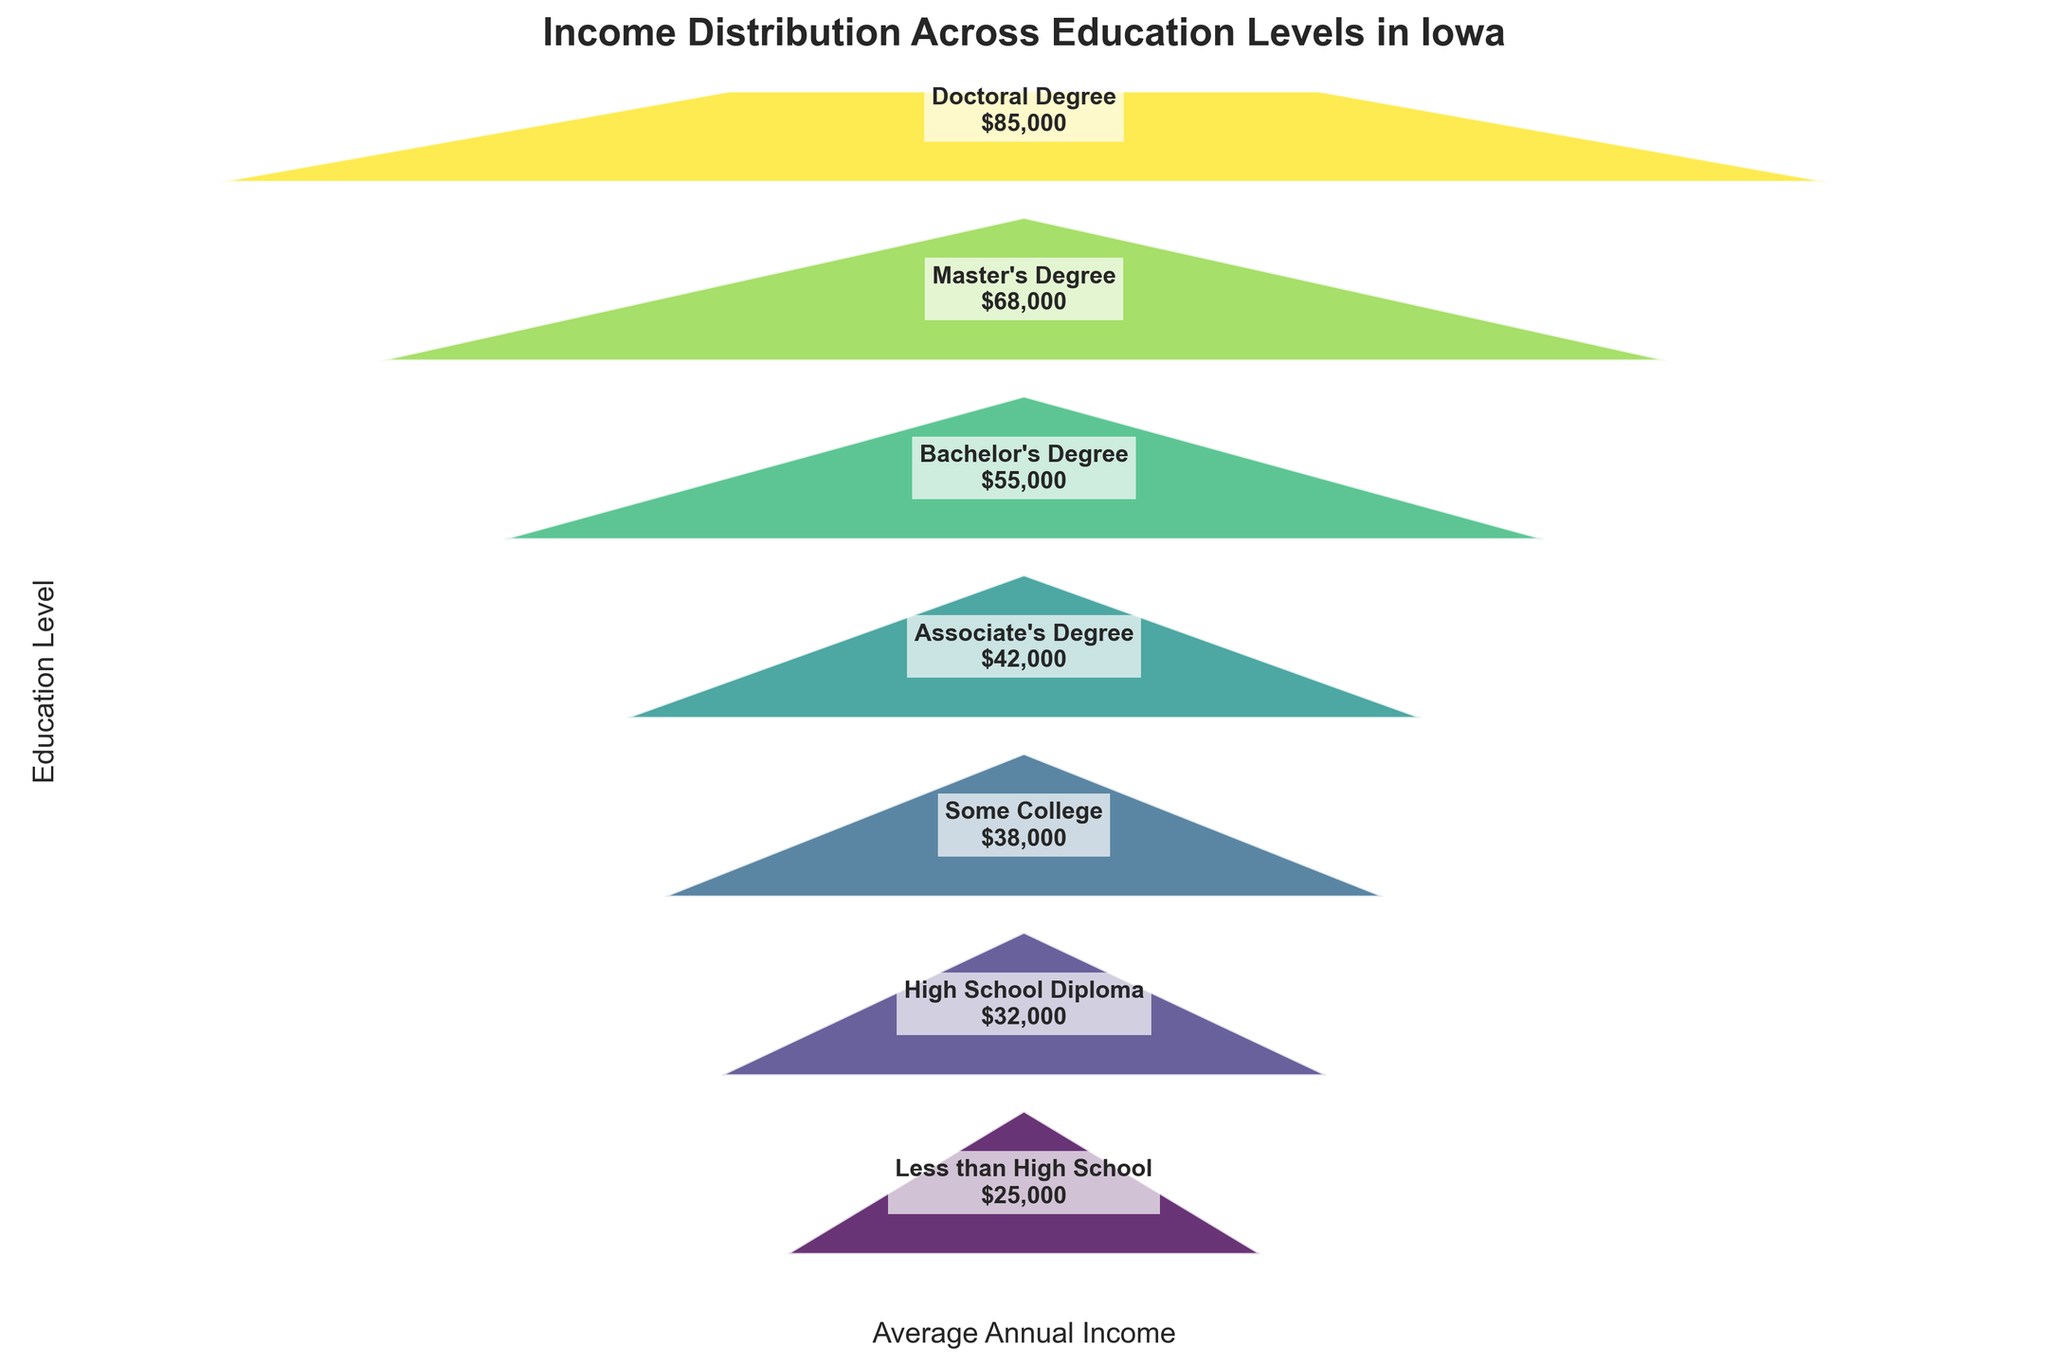What's the title of the figure? The title is shown at the top of the figure and summarizes the main topic of the chart.
Answer: Income Distribution Across Education Levels in Iowa Which education level has the lowest average annual income? Examine the funnel chart from top to bottom and find the section corresponding to the lowest income.
Answer: Less than High School What is the average annual income for someone with a Bachelor's Degree? Locate the section of the funnel chart labeled "Bachelor's Degree" and check the income value inside it.
Answer: $55,000 How much more does someone with a Doctoral Degree make compared to someone with only a High School Diploma? Find the income values for Doctoral Degree and High School Diploma. Subtract the High School Diploma income from the Doctoral Degree income: $85,000 - $32,000 = $53,000.
Answer: $53,000 Which two education levels have an average annual income difference of $18,000? Identify pairs of adjacent education levels and calculate their income differences to find the pair with a difference of $18,000. The difference is $68,000 - $50,000 for Master's Degree and Bachelor's Degree.
Answer: Master's Degree and Bachelor's Degree What is the average income of individuals with an Associate's Degree and some College? Add the incomes for Associate's Degree and Some College, then divide by 2: ($42,000 + $38,000) / 2 = $40,000.
Answer: $40,000 By how much does the income increase from High School Diploma to Some College? Subtract the High School Diploma income from the Some College income: $38,000 - $32,000 = $6,000.
Answer: $6,000 What is the range of incomes presented in this chart? Identify the highest and lowest income values in the chart and subtract the smallest from the largest: $85,000 - $25,000 = $60,000.
Answer: $60,000 How does the funnel chart visually represent the difference in income among education levels? Observe the width of each section, which varies according to income. The wider the section, the higher the income, and the hierarchy depicts increasing educational attainment from bottom to top.
Answer: Width of sections What trend is observed in income when educational attainment increases from Less than High School to Doctoral Degree? Moving from the bottom to the top of the chart shows incomes increasing as educational levels rise. The income generally increases consistently with higher education.
Answer: Income increases 